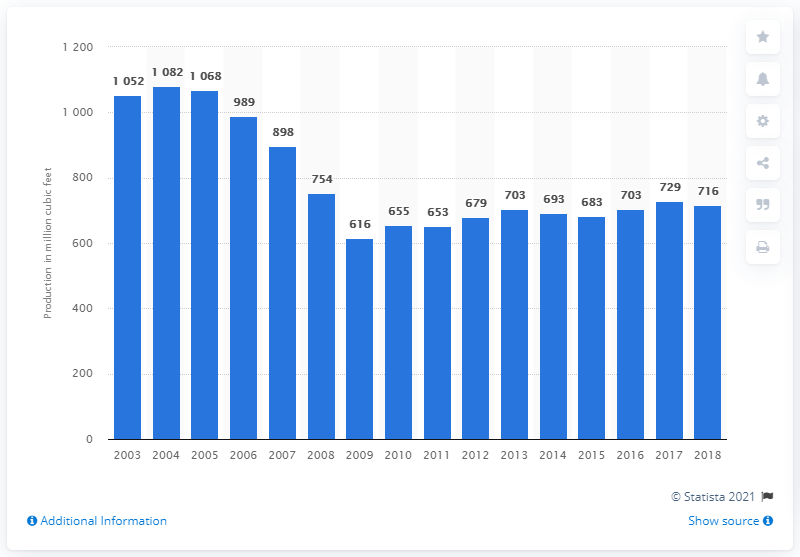Identify some key points in this picture. The total production of plywood and veneer in the United States in 2018 was 716.. 